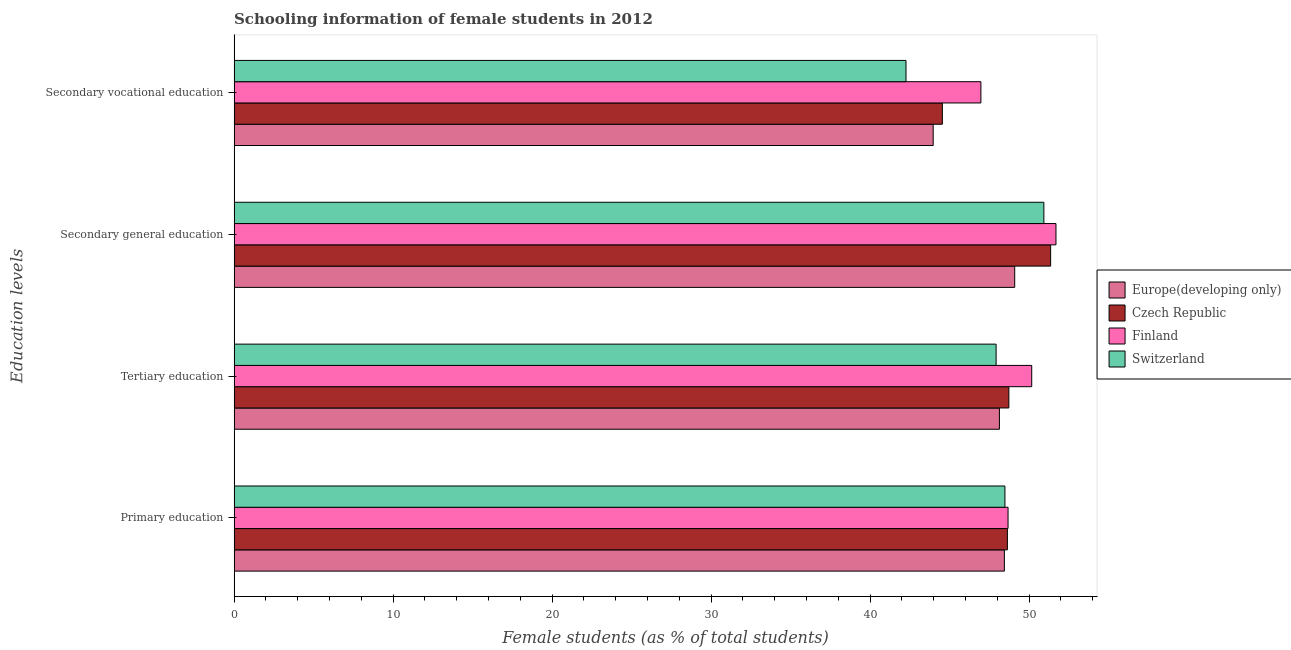How many groups of bars are there?
Offer a very short reply. 4. What is the label of the 2nd group of bars from the top?
Provide a short and direct response. Secondary general education. What is the percentage of female students in secondary vocational education in Finland?
Offer a very short reply. 46.97. Across all countries, what is the maximum percentage of female students in secondary education?
Make the answer very short. 51.69. Across all countries, what is the minimum percentage of female students in primary education?
Offer a very short reply. 48.45. In which country was the percentage of female students in primary education minimum?
Ensure brevity in your answer.  Europe(developing only). What is the total percentage of female students in secondary vocational education in the graph?
Your answer should be compact. 177.75. What is the difference between the percentage of female students in primary education in Switzerland and that in Czech Republic?
Your response must be concise. -0.15. What is the difference between the percentage of female students in primary education in Czech Republic and the percentage of female students in secondary education in Finland?
Your answer should be compact. -3.06. What is the average percentage of female students in secondary education per country?
Your response must be concise. 50.77. What is the difference between the percentage of female students in tertiary education and percentage of female students in secondary vocational education in Europe(developing only)?
Provide a short and direct response. 4.17. What is the ratio of the percentage of female students in primary education in Czech Republic to that in Finland?
Make the answer very short. 1. Is the percentage of female students in tertiary education in Czech Republic less than that in Europe(developing only)?
Offer a very short reply. No. Is the difference between the percentage of female students in secondary vocational education in Finland and Czech Republic greater than the difference between the percentage of female students in primary education in Finland and Czech Republic?
Give a very brief answer. Yes. What is the difference between the highest and the second highest percentage of female students in primary education?
Your response must be concise. 0.04. What is the difference between the highest and the lowest percentage of female students in secondary education?
Offer a terse response. 2.59. In how many countries, is the percentage of female students in secondary education greater than the average percentage of female students in secondary education taken over all countries?
Provide a succinct answer. 3. Is it the case that in every country, the sum of the percentage of female students in secondary vocational education and percentage of female students in tertiary education is greater than the sum of percentage of female students in primary education and percentage of female students in secondary education?
Ensure brevity in your answer.  No. What does the 1st bar from the top in Secondary general education represents?
Your answer should be compact. Switzerland. What does the 4th bar from the bottom in Primary education represents?
Give a very brief answer. Switzerland. Is it the case that in every country, the sum of the percentage of female students in primary education and percentage of female students in tertiary education is greater than the percentage of female students in secondary education?
Keep it short and to the point. Yes. Are all the bars in the graph horizontal?
Keep it short and to the point. Yes. Where does the legend appear in the graph?
Your answer should be compact. Center right. How are the legend labels stacked?
Provide a succinct answer. Vertical. What is the title of the graph?
Give a very brief answer. Schooling information of female students in 2012. What is the label or title of the X-axis?
Your answer should be compact. Female students (as % of total students). What is the label or title of the Y-axis?
Make the answer very short. Education levels. What is the Female students (as % of total students) in Europe(developing only) in Primary education?
Provide a succinct answer. 48.45. What is the Female students (as % of total students) in Czech Republic in Primary education?
Ensure brevity in your answer.  48.64. What is the Female students (as % of total students) of Finland in Primary education?
Ensure brevity in your answer.  48.68. What is the Female students (as % of total students) in Switzerland in Primary education?
Offer a very short reply. 48.48. What is the Female students (as % of total students) of Europe(developing only) in Tertiary education?
Keep it short and to the point. 48.14. What is the Female students (as % of total students) in Czech Republic in Tertiary education?
Your answer should be compact. 48.73. What is the Female students (as % of total students) in Finland in Tertiary education?
Ensure brevity in your answer.  50.17. What is the Female students (as % of total students) in Switzerland in Tertiary education?
Provide a succinct answer. 47.93. What is the Female students (as % of total students) of Europe(developing only) in Secondary general education?
Keep it short and to the point. 49.1. What is the Female students (as % of total students) of Czech Republic in Secondary general education?
Offer a terse response. 51.36. What is the Female students (as % of total students) in Finland in Secondary general education?
Your answer should be compact. 51.69. What is the Female students (as % of total students) of Switzerland in Secondary general education?
Make the answer very short. 50.93. What is the Female students (as % of total students) in Europe(developing only) in Secondary vocational education?
Your answer should be very brief. 43.97. What is the Female students (as % of total students) in Czech Republic in Secondary vocational education?
Provide a short and direct response. 44.55. What is the Female students (as % of total students) in Finland in Secondary vocational education?
Offer a terse response. 46.97. What is the Female students (as % of total students) of Switzerland in Secondary vocational education?
Provide a short and direct response. 42.26. Across all Education levels, what is the maximum Female students (as % of total students) in Europe(developing only)?
Your answer should be very brief. 49.1. Across all Education levels, what is the maximum Female students (as % of total students) in Czech Republic?
Make the answer very short. 51.36. Across all Education levels, what is the maximum Female students (as % of total students) in Finland?
Keep it short and to the point. 51.69. Across all Education levels, what is the maximum Female students (as % of total students) in Switzerland?
Your answer should be very brief. 50.93. Across all Education levels, what is the minimum Female students (as % of total students) of Europe(developing only)?
Offer a terse response. 43.97. Across all Education levels, what is the minimum Female students (as % of total students) of Czech Republic?
Make the answer very short. 44.55. Across all Education levels, what is the minimum Female students (as % of total students) of Finland?
Give a very brief answer. 46.97. Across all Education levels, what is the minimum Female students (as % of total students) in Switzerland?
Give a very brief answer. 42.26. What is the total Female students (as % of total students) in Europe(developing only) in the graph?
Offer a very short reply. 189.65. What is the total Female students (as % of total students) in Czech Republic in the graph?
Offer a very short reply. 193.27. What is the total Female students (as % of total students) of Finland in the graph?
Make the answer very short. 197.51. What is the total Female students (as % of total students) in Switzerland in the graph?
Ensure brevity in your answer.  189.6. What is the difference between the Female students (as % of total students) of Europe(developing only) in Primary education and that in Tertiary education?
Keep it short and to the point. 0.31. What is the difference between the Female students (as % of total students) of Czech Republic in Primary education and that in Tertiary education?
Keep it short and to the point. -0.09. What is the difference between the Female students (as % of total students) in Finland in Primary education and that in Tertiary education?
Provide a short and direct response. -1.49. What is the difference between the Female students (as % of total students) in Switzerland in Primary education and that in Tertiary education?
Your answer should be compact. 0.55. What is the difference between the Female students (as % of total students) of Europe(developing only) in Primary education and that in Secondary general education?
Your response must be concise. -0.65. What is the difference between the Female students (as % of total students) of Czech Republic in Primary education and that in Secondary general education?
Make the answer very short. -2.72. What is the difference between the Female students (as % of total students) in Finland in Primary education and that in Secondary general education?
Offer a terse response. -3.01. What is the difference between the Female students (as % of total students) in Switzerland in Primary education and that in Secondary general education?
Offer a very short reply. -2.45. What is the difference between the Female students (as % of total students) of Europe(developing only) in Primary education and that in Secondary vocational education?
Make the answer very short. 4.48. What is the difference between the Female students (as % of total students) in Czech Republic in Primary education and that in Secondary vocational education?
Your answer should be very brief. 4.09. What is the difference between the Female students (as % of total students) of Finland in Primary education and that in Secondary vocational education?
Offer a very short reply. 1.71. What is the difference between the Female students (as % of total students) in Switzerland in Primary education and that in Secondary vocational education?
Give a very brief answer. 6.22. What is the difference between the Female students (as % of total students) of Europe(developing only) in Tertiary education and that in Secondary general education?
Your answer should be compact. -0.96. What is the difference between the Female students (as % of total students) in Czech Republic in Tertiary education and that in Secondary general education?
Your response must be concise. -2.63. What is the difference between the Female students (as % of total students) in Finland in Tertiary education and that in Secondary general education?
Make the answer very short. -1.52. What is the difference between the Female students (as % of total students) of Switzerland in Tertiary education and that in Secondary general education?
Keep it short and to the point. -3.01. What is the difference between the Female students (as % of total students) of Europe(developing only) in Tertiary education and that in Secondary vocational education?
Your answer should be compact. 4.17. What is the difference between the Female students (as % of total students) in Czech Republic in Tertiary education and that in Secondary vocational education?
Ensure brevity in your answer.  4.18. What is the difference between the Female students (as % of total students) of Finland in Tertiary education and that in Secondary vocational education?
Provide a short and direct response. 3.2. What is the difference between the Female students (as % of total students) in Switzerland in Tertiary education and that in Secondary vocational education?
Provide a short and direct response. 5.67. What is the difference between the Female students (as % of total students) in Europe(developing only) in Secondary general education and that in Secondary vocational education?
Your answer should be compact. 5.13. What is the difference between the Female students (as % of total students) of Czech Republic in Secondary general education and that in Secondary vocational education?
Ensure brevity in your answer.  6.81. What is the difference between the Female students (as % of total students) in Finland in Secondary general education and that in Secondary vocational education?
Ensure brevity in your answer.  4.72. What is the difference between the Female students (as % of total students) of Switzerland in Secondary general education and that in Secondary vocational education?
Your answer should be very brief. 8.67. What is the difference between the Female students (as % of total students) in Europe(developing only) in Primary education and the Female students (as % of total students) in Czech Republic in Tertiary education?
Ensure brevity in your answer.  -0.28. What is the difference between the Female students (as % of total students) of Europe(developing only) in Primary education and the Female students (as % of total students) of Finland in Tertiary education?
Ensure brevity in your answer.  -1.72. What is the difference between the Female students (as % of total students) in Europe(developing only) in Primary education and the Female students (as % of total students) in Switzerland in Tertiary education?
Offer a terse response. 0.52. What is the difference between the Female students (as % of total students) in Czech Republic in Primary education and the Female students (as % of total students) in Finland in Tertiary education?
Ensure brevity in your answer.  -1.53. What is the difference between the Female students (as % of total students) of Czech Republic in Primary education and the Female students (as % of total students) of Switzerland in Tertiary education?
Keep it short and to the point. 0.71. What is the difference between the Female students (as % of total students) of Finland in Primary education and the Female students (as % of total students) of Switzerland in Tertiary education?
Make the answer very short. 0.75. What is the difference between the Female students (as % of total students) in Europe(developing only) in Primary education and the Female students (as % of total students) in Czech Republic in Secondary general education?
Give a very brief answer. -2.91. What is the difference between the Female students (as % of total students) of Europe(developing only) in Primary education and the Female students (as % of total students) of Finland in Secondary general education?
Offer a terse response. -3.24. What is the difference between the Female students (as % of total students) of Europe(developing only) in Primary education and the Female students (as % of total students) of Switzerland in Secondary general education?
Keep it short and to the point. -2.48. What is the difference between the Female students (as % of total students) in Czech Republic in Primary education and the Female students (as % of total students) in Finland in Secondary general education?
Give a very brief answer. -3.06. What is the difference between the Female students (as % of total students) in Czech Republic in Primary education and the Female students (as % of total students) in Switzerland in Secondary general education?
Provide a succinct answer. -2.3. What is the difference between the Female students (as % of total students) of Finland in Primary education and the Female students (as % of total students) of Switzerland in Secondary general education?
Ensure brevity in your answer.  -2.25. What is the difference between the Female students (as % of total students) of Europe(developing only) in Primary education and the Female students (as % of total students) of Czech Republic in Secondary vocational education?
Your answer should be compact. 3.9. What is the difference between the Female students (as % of total students) of Europe(developing only) in Primary education and the Female students (as % of total students) of Finland in Secondary vocational education?
Your answer should be compact. 1.48. What is the difference between the Female students (as % of total students) of Europe(developing only) in Primary education and the Female students (as % of total students) of Switzerland in Secondary vocational education?
Ensure brevity in your answer.  6.19. What is the difference between the Female students (as % of total students) in Czech Republic in Primary education and the Female students (as % of total students) in Finland in Secondary vocational education?
Provide a short and direct response. 1.67. What is the difference between the Female students (as % of total students) of Czech Republic in Primary education and the Female students (as % of total students) of Switzerland in Secondary vocational education?
Your answer should be very brief. 6.38. What is the difference between the Female students (as % of total students) of Finland in Primary education and the Female students (as % of total students) of Switzerland in Secondary vocational education?
Ensure brevity in your answer.  6.42. What is the difference between the Female students (as % of total students) in Europe(developing only) in Tertiary education and the Female students (as % of total students) in Czech Republic in Secondary general education?
Provide a short and direct response. -3.22. What is the difference between the Female students (as % of total students) of Europe(developing only) in Tertiary education and the Female students (as % of total students) of Finland in Secondary general education?
Ensure brevity in your answer.  -3.56. What is the difference between the Female students (as % of total students) of Europe(developing only) in Tertiary education and the Female students (as % of total students) of Switzerland in Secondary general education?
Your response must be concise. -2.8. What is the difference between the Female students (as % of total students) in Czech Republic in Tertiary education and the Female students (as % of total students) in Finland in Secondary general education?
Make the answer very short. -2.96. What is the difference between the Female students (as % of total students) of Czech Republic in Tertiary education and the Female students (as % of total students) of Switzerland in Secondary general education?
Your answer should be compact. -2.2. What is the difference between the Female students (as % of total students) of Finland in Tertiary education and the Female students (as % of total students) of Switzerland in Secondary general education?
Your answer should be very brief. -0.76. What is the difference between the Female students (as % of total students) in Europe(developing only) in Tertiary education and the Female students (as % of total students) in Czech Republic in Secondary vocational education?
Offer a terse response. 3.59. What is the difference between the Female students (as % of total students) in Europe(developing only) in Tertiary education and the Female students (as % of total students) in Finland in Secondary vocational education?
Your response must be concise. 1.17. What is the difference between the Female students (as % of total students) in Europe(developing only) in Tertiary education and the Female students (as % of total students) in Switzerland in Secondary vocational education?
Provide a succinct answer. 5.88. What is the difference between the Female students (as % of total students) in Czech Republic in Tertiary education and the Female students (as % of total students) in Finland in Secondary vocational education?
Give a very brief answer. 1.76. What is the difference between the Female students (as % of total students) of Czech Republic in Tertiary education and the Female students (as % of total students) of Switzerland in Secondary vocational education?
Provide a short and direct response. 6.47. What is the difference between the Female students (as % of total students) of Finland in Tertiary education and the Female students (as % of total students) of Switzerland in Secondary vocational education?
Give a very brief answer. 7.91. What is the difference between the Female students (as % of total students) in Europe(developing only) in Secondary general education and the Female students (as % of total students) in Czech Republic in Secondary vocational education?
Give a very brief answer. 4.55. What is the difference between the Female students (as % of total students) of Europe(developing only) in Secondary general education and the Female students (as % of total students) of Finland in Secondary vocational education?
Your answer should be compact. 2.13. What is the difference between the Female students (as % of total students) of Europe(developing only) in Secondary general education and the Female students (as % of total students) of Switzerland in Secondary vocational education?
Your answer should be very brief. 6.84. What is the difference between the Female students (as % of total students) of Czech Republic in Secondary general education and the Female students (as % of total students) of Finland in Secondary vocational education?
Keep it short and to the point. 4.39. What is the difference between the Female students (as % of total students) in Czech Republic in Secondary general education and the Female students (as % of total students) in Switzerland in Secondary vocational education?
Ensure brevity in your answer.  9.1. What is the difference between the Female students (as % of total students) of Finland in Secondary general education and the Female students (as % of total students) of Switzerland in Secondary vocational education?
Provide a short and direct response. 9.43. What is the average Female students (as % of total students) in Europe(developing only) per Education levels?
Your answer should be compact. 47.41. What is the average Female students (as % of total students) of Czech Republic per Education levels?
Provide a short and direct response. 48.32. What is the average Female students (as % of total students) of Finland per Education levels?
Keep it short and to the point. 49.38. What is the average Female students (as % of total students) in Switzerland per Education levels?
Ensure brevity in your answer.  47.4. What is the difference between the Female students (as % of total students) in Europe(developing only) and Female students (as % of total students) in Czech Republic in Primary education?
Offer a terse response. -0.19. What is the difference between the Female students (as % of total students) of Europe(developing only) and Female students (as % of total students) of Finland in Primary education?
Provide a short and direct response. -0.23. What is the difference between the Female students (as % of total students) in Europe(developing only) and Female students (as % of total students) in Switzerland in Primary education?
Provide a succinct answer. -0.03. What is the difference between the Female students (as % of total students) in Czech Republic and Female students (as % of total students) in Finland in Primary education?
Offer a very short reply. -0.04. What is the difference between the Female students (as % of total students) of Czech Republic and Female students (as % of total students) of Switzerland in Primary education?
Your answer should be very brief. 0.15. What is the difference between the Female students (as % of total students) in Finland and Female students (as % of total students) in Switzerland in Primary education?
Offer a terse response. 0.2. What is the difference between the Female students (as % of total students) in Europe(developing only) and Female students (as % of total students) in Czech Republic in Tertiary education?
Give a very brief answer. -0.59. What is the difference between the Female students (as % of total students) of Europe(developing only) and Female students (as % of total students) of Finland in Tertiary education?
Offer a terse response. -2.03. What is the difference between the Female students (as % of total students) of Europe(developing only) and Female students (as % of total students) of Switzerland in Tertiary education?
Offer a very short reply. 0.21. What is the difference between the Female students (as % of total students) of Czech Republic and Female students (as % of total students) of Finland in Tertiary education?
Provide a succinct answer. -1.44. What is the difference between the Female students (as % of total students) of Czech Republic and Female students (as % of total students) of Switzerland in Tertiary education?
Provide a short and direct response. 0.8. What is the difference between the Female students (as % of total students) in Finland and Female students (as % of total students) in Switzerland in Tertiary education?
Ensure brevity in your answer.  2.24. What is the difference between the Female students (as % of total students) in Europe(developing only) and Female students (as % of total students) in Czech Republic in Secondary general education?
Keep it short and to the point. -2.26. What is the difference between the Female students (as % of total students) of Europe(developing only) and Female students (as % of total students) of Finland in Secondary general education?
Your answer should be very brief. -2.59. What is the difference between the Female students (as % of total students) of Europe(developing only) and Female students (as % of total students) of Switzerland in Secondary general education?
Your answer should be very brief. -1.83. What is the difference between the Female students (as % of total students) of Czech Republic and Female students (as % of total students) of Finland in Secondary general education?
Your response must be concise. -0.33. What is the difference between the Female students (as % of total students) of Czech Republic and Female students (as % of total students) of Switzerland in Secondary general education?
Your answer should be compact. 0.43. What is the difference between the Female students (as % of total students) in Finland and Female students (as % of total students) in Switzerland in Secondary general education?
Keep it short and to the point. 0.76. What is the difference between the Female students (as % of total students) of Europe(developing only) and Female students (as % of total students) of Czech Republic in Secondary vocational education?
Make the answer very short. -0.58. What is the difference between the Female students (as % of total students) in Europe(developing only) and Female students (as % of total students) in Finland in Secondary vocational education?
Provide a succinct answer. -3. What is the difference between the Female students (as % of total students) in Europe(developing only) and Female students (as % of total students) in Switzerland in Secondary vocational education?
Offer a very short reply. 1.71. What is the difference between the Female students (as % of total students) in Czech Republic and Female students (as % of total students) in Finland in Secondary vocational education?
Give a very brief answer. -2.42. What is the difference between the Female students (as % of total students) in Czech Republic and Female students (as % of total students) in Switzerland in Secondary vocational education?
Provide a short and direct response. 2.29. What is the difference between the Female students (as % of total students) of Finland and Female students (as % of total students) of Switzerland in Secondary vocational education?
Your answer should be very brief. 4.71. What is the ratio of the Female students (as % of total students) in Finland in Primary education to that in Tertiary education?
Make the answer very short. 0.97. What is the ratio of the Female students (as % of total students) of Switzerland in Primary education to that in Tertiary education?
Give a very brief answer. 1.01. What is the ratio of the Female students (as % of total students) in Czech Republic in Primary education to that in Secondary general education?
Ensure brevity in your answer.  0.95. What is the ratio of the Female students (as % of total students) in Finland in Primary education to that in Secondary general education?
Your answer should be very brief. 0.94. What is the ratio of the Female students (as % of total students) of Switzerland in Primary education to that in Secondary general education?
Provide a succinct answer. 0.95. What is the ratio of the Female students (as % of total students) in Europe(developing only) in Primary education to that in Secondary vocational education?
Your answer should be very brief. 1.1. What is the ratio of the Female students (as % of total students) of Czech Republic in Primary education to that in Secondary vocational education?
Provide a short and direct response. 1.09. What is the ratio of the Female students (as % of total students) in Finland in Primary education to that in Secondary vocational education?
Your answer should be compact. 1.04. What is the ratio of the Female students (as % of total students) in Switzerland in Primary education to that in Secondary vocational education?
Provide a short and direct response. 1.15. What is the ratio of the Female students (as % of total students) of Europe(developing only) in Tertiary education to that in Secondary general education?
Your answer should be compact. 0.98. What is the ratio of the Female students (as % of total students) of Czech Republic in Tertiary education to that in Secondary general education?
Make the answer very short. 0.95. What is the ratio of the Female students (as % of total students) of Finland in Tertiary education to that in Secondary general education?
Offer a very short reply. 0.97. What is the ratio of the Female students (as % of total students) in Switzerland in Tertiary education to that in Secondary general education?
Provide a succinct answer. 0.94. What is the ratio of the Female students (as % of total students) of Europe(developing only) in Tertiary education to that in Secondary vocational education?
Keep it short and to the point. 1.09. What is the ratio of the Female students (as % of total students) of Czech Republic in Tertiary education to that in Secondary vocational education?
Provide a short and direct response. 1.09. What is the ratio of the Female students (as % of total students) of Finland in Tertiary education to that in Secondary vocational education?
Your response must be concise. 1.07. What is the ratio of the Female students (as % of total students) of Switzerland in Tertiary education to that in Secondary vocational education?
Offer a very short reply. 1.13. What is the ratio of the Female students (as % of total students) of Europe(developing only) in Secondary general education to that in Secondary vocational education?
Offer a very short reply. 1.12. What is the ratio of the Female students (as % of total students) in Czech Republic in Secondary general education to that in Secondary vocational education?
Offer a very short reply. 1.15. What is the ratio of the Female students (as % of total students) of Finland in Secondary general education to that in Secondary vocational education?
Your answer should be compact. 1.1. What is the ratio of the Female students (as % of total students) in Switzerland in Secondary general education to that in Secondary vocational education?
Your answer should be very brief. 1.21. What is the difference between the highest and the second highest Female students (as % of total students) in Europe(developing only)?
Ensure brevity in your answer.  0.65. What is the difference between the highest and the second highest Female students (as % of total students) of Czech Republic?
Make the answer very short. 2.63. What is the difference between the highest and the second highest Female students (as % of total students) in Finland?
Keep it short and to the point. 1.52. What is the difference between the highest and the second highest Female students (as % of total students) in Switzerland?
Offer a very short reply. 2.45. What is the difference between the highest and the lowest Female students (as % of total students) of Europe(developing only)?
Provide a succinct answer. 5.13. What is the difference between the highest and the lowest Female students (as % of total students) in Czech Republic?
Offer a terse response. 6.81. What is the difference between the highest and the lowest Female students (as % of total students) of Finland?
Keep it short and to the point. 4.72. What is the difference between the highest and the lowest Female students (as % of total students) in Switzerland?
Offer a very short reply. 8.67. 